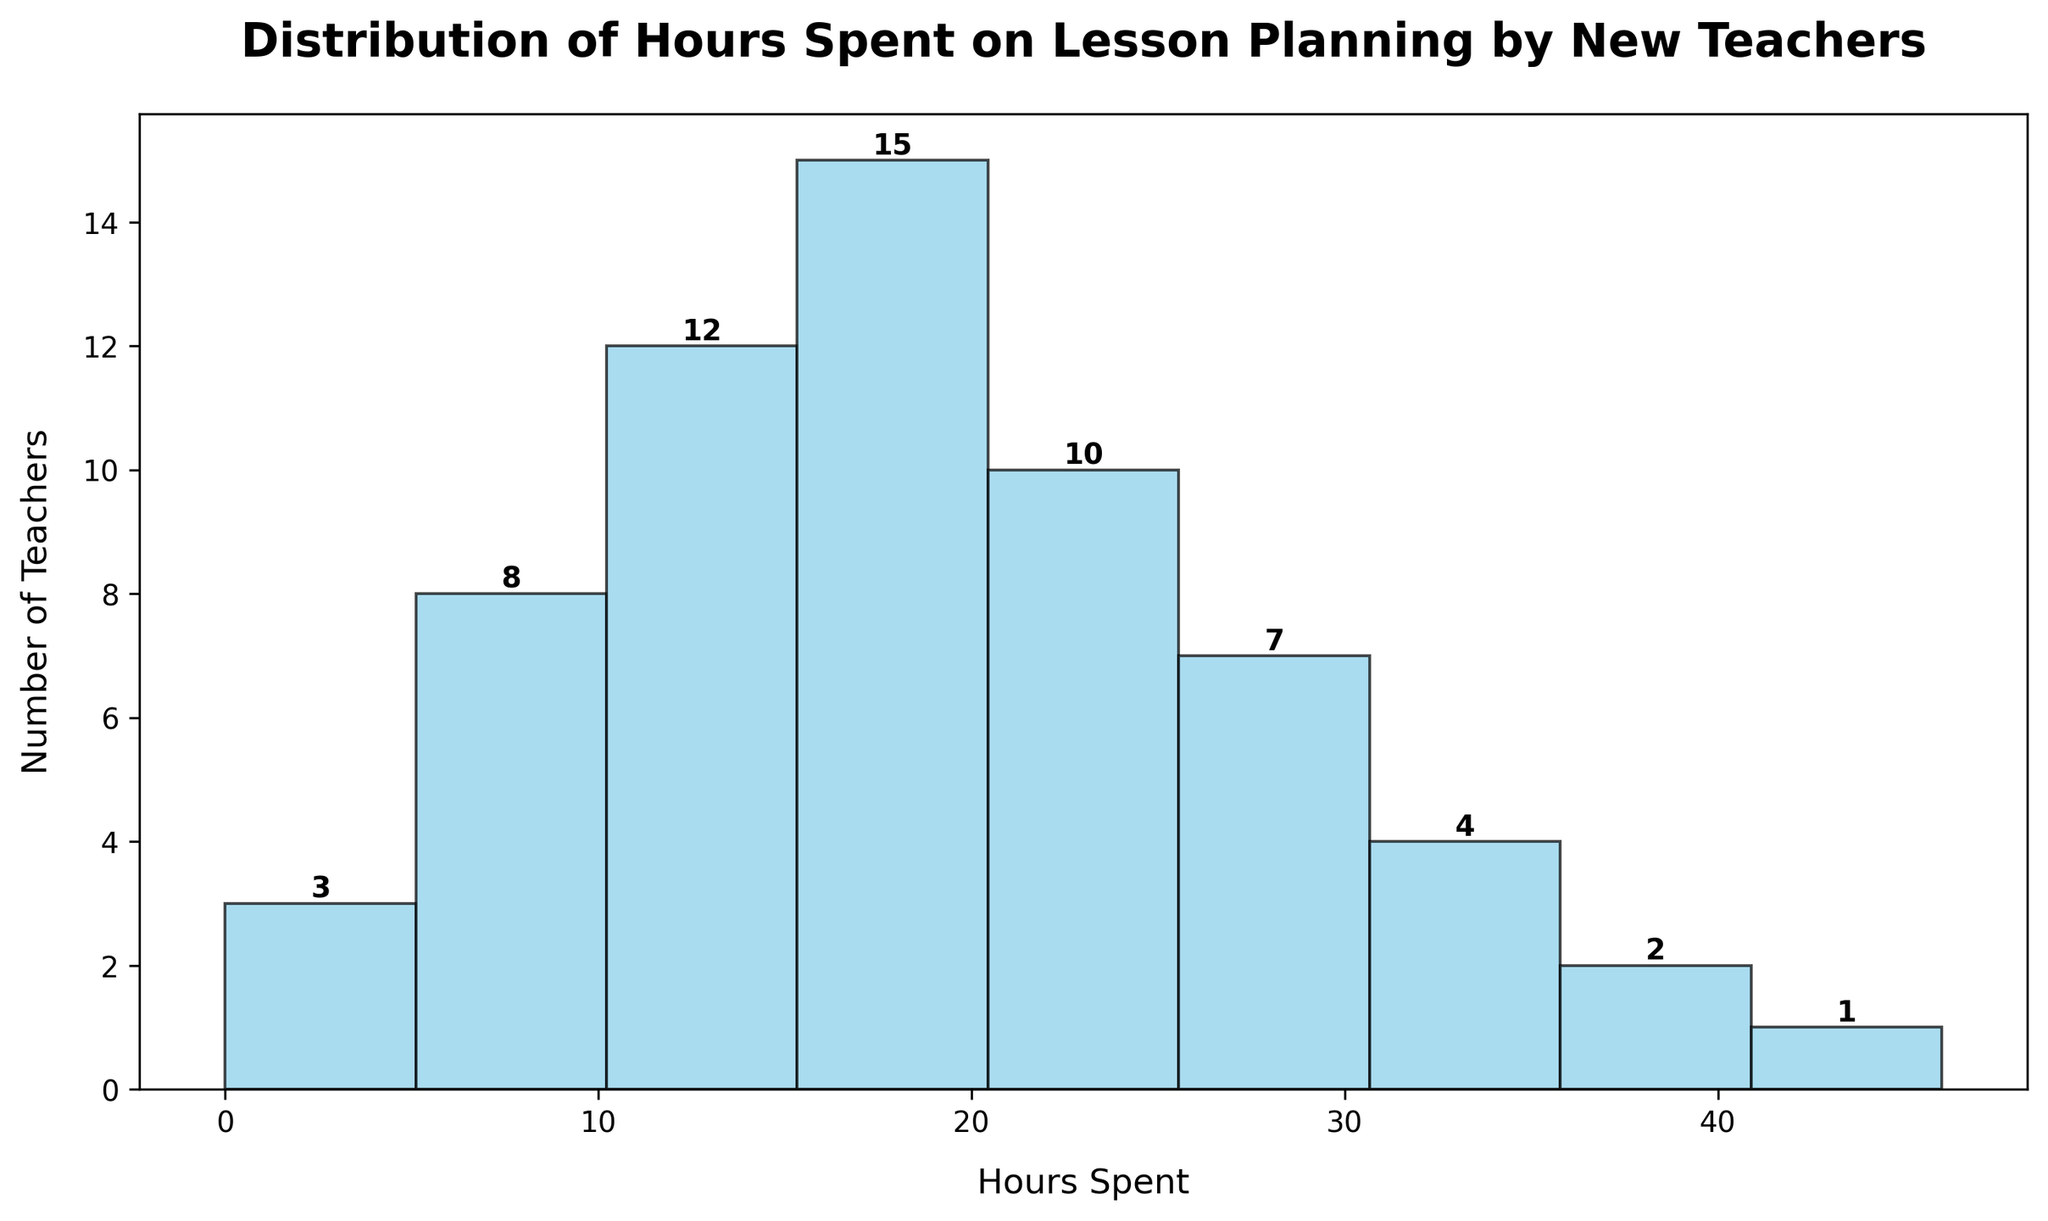What is the title of the histogram? At the top of the plot, it's clearly stated in bold. The title is 'Distribution of Hours Spent on Lesson Planning by New Teachers'.
Answer: 'Distribution of Hours Spent on Lesson Planning by New Teachers' What is the range of hours spent on lesson planning that has the highest number of teachers? By looking at the height of the bars, the tallest one represents the range 16-20 hours.
Answer: 16-20 hours How many teachers spend between 11 and 15 hours on lesson planning? The bar corresponding to the 11-15 hours range is labeled with the number of teachers at the top. It reads 12 teachers.
Answer: 12 teachers Which range of hours spent on lesson planning has the least number of teachers? The shortest bar is the one that corresponds to the 41-45 hours range, which has the label of 1 teacher.
Answer: 41-45 hours How many teachers spend more than 25 hours on lesson planning? Add the number of teachers from the ranges 26-30, 31-35, 36-40, and 41-45. That's 7 + 4 + 2 + 1 = 14 teachers.
Answer: 14 teachers By how much does the number of teachers spending 11-15 hours exceed the number spending 21-25 hours? Subtract the number in the 21-25 range from the number in the 11-15 range: 12 - 10 = 2 teachers.
Answer: 2 teachers How many more teachers spend 16-20 hours than those who spend 6-10 hours? Subtract the number in the 6-10 range from the number in the 16-20 range: 15 - 8 = 7 teachers.
Answer: 7 teachers What is the median range of hours spent on lesson planning? Identify the middle value in the ordered numbers of teachers' populations. Considering the cumulative count and finding the middle one, it falls within the 16-20 hour range.
Answer: 16-20 hours Compare the number of teachers who spend 0-5 hours with those spending 26-30 hours on lesson planning. Which is greater and by how much? Subtracting the number for 0-5 hours (3) from that of 26-30 hours (7): 7 - 3 = 4 teachers. The 26-30 hour range is greater.
Answer: 26-30 hours by 4 